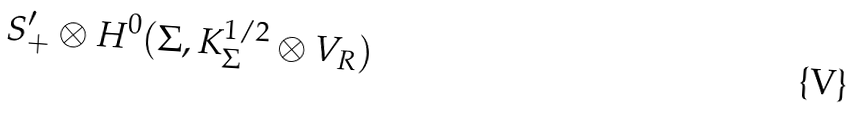Convert formula to latex. <formula><loc_0><loc_0><loc_500><loc_500>S _ { + } ^ { \prime } \otimes H ^ { 0 } ( \Sigma , K _ { \Sigma } ^ { 1 / 2 } \otimes V _ { R } )</formula> 